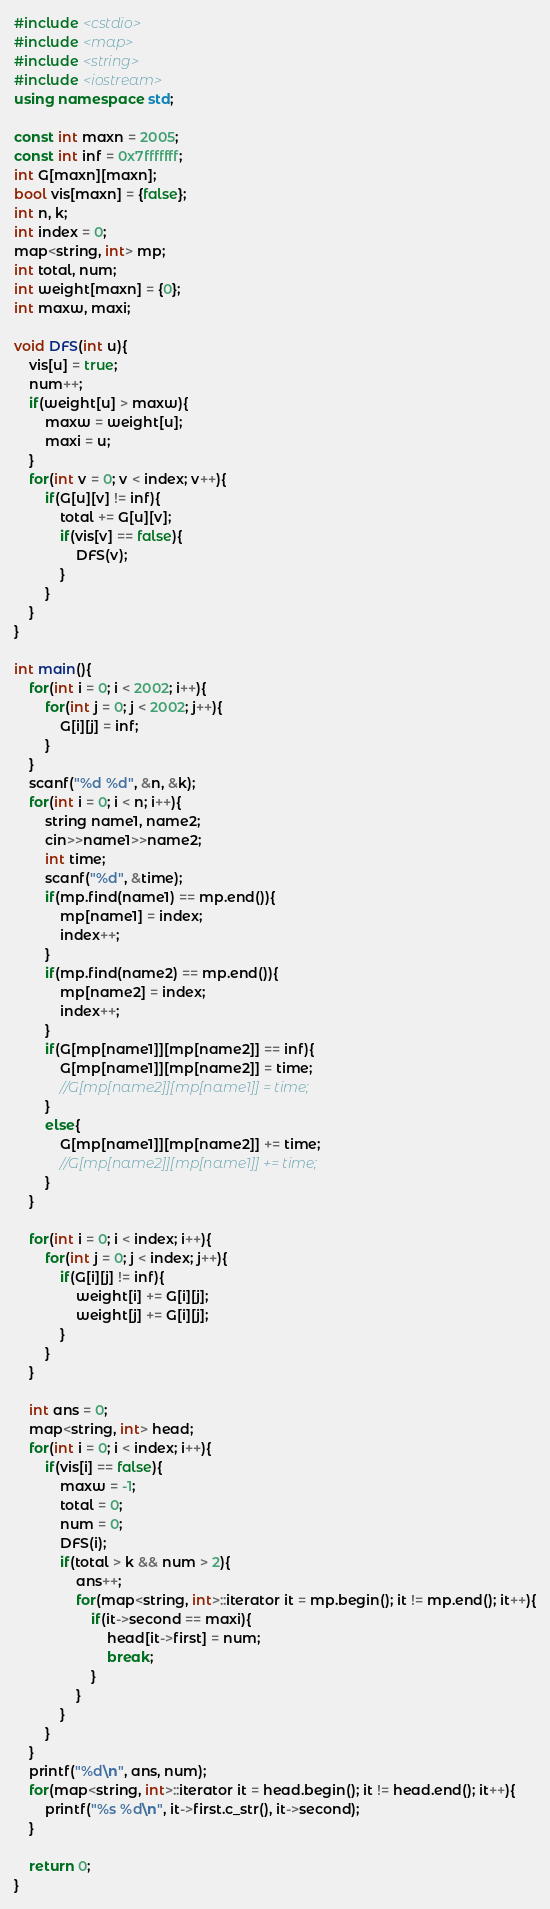<code> <loc_0><loc_0><loc_500><loc_500><_C++_>#include <cstdio>
#include <map>
#include <string>
#include <iostream>
using namespace std;

const int maxn = 2005;
const int inf = 0x7fffffff;
int G[maxn][maxn];
bool vis[maxn] = {false};
int n, k;
int index = 0;
map<string, int> mp;
int total, num;
int weight[maxn] = {0};
int maxw, maxi;

void DFS(int u){
    vis[u] = true;
    num++;
    if(weight[u] > maxw){
        maxw = weight[u];
        maxi = u;
    }
    for(int v = 0; v < index; v++){
        if(G[u][v] != inf){
            total += G[u][v];
            if(vis[v] == false){
                DFS(v);
            } 
        }
    }
}

int main(){
    for(int i = 0; i < 2002; i++){
        for(int j = 0; j < 2002; j++){
            G[i][j] = inf;
        }
    }
    scanf("%d %d", &n, &k);
    for(int i = 0; i < n; i++){
        string name1, name2;
        cin>>name1>>name2;
        int time;
        scanf("%d", &time);
        if(mp.find(name1) == mp.end()){
            mp[name1] = index;
            index++;
        }
        if(mp.find(name2) == mp.end()){
            mp[name2] = index;
            index++;
        }
        if(G[mp[name1]][mp[name2]] == inf){
            G[mp[name1]][mp[name2]] = time;
            //G[mp[name2]][mp[name1]] = time;
        }
        else{
            G[mp[name1]][mp[name2]] += time;
            //G[mp[name2]][mp[name1]] += time;
        }
    }

    for(int i = 0; i < index; i++){
        for(int j = 0; j < index; j++){
            if(G[i][j] != inf){
                weight[i] += G[i][j];
                weight[j] += G[i][j];
            }
        }
    }

    int ans = 0;
    map<string, int> head;
    for(int i = 0; i < index; i++){
        if(vis[i] == false){
            maxw = -1;
            total = 0;
            num = 0;
            DFS(i);
            if(total > k && num > 2){
                ans++;
                for(map<string, int>::iterator it = mp.begin(); it != mp.end(); it++){
                    if(it->second == maxi){
                        head[it->first] = num;
                        break;
                    }
                }
            }
        }
    }
    printf("%d\n", ans, num);
    for(map<string, int>::iterator it = head.begin(); it != head.end(); it++){
        printf("%s %d\n", it->first.c_str(), it->second);
    }

    return 0;
}</code> 